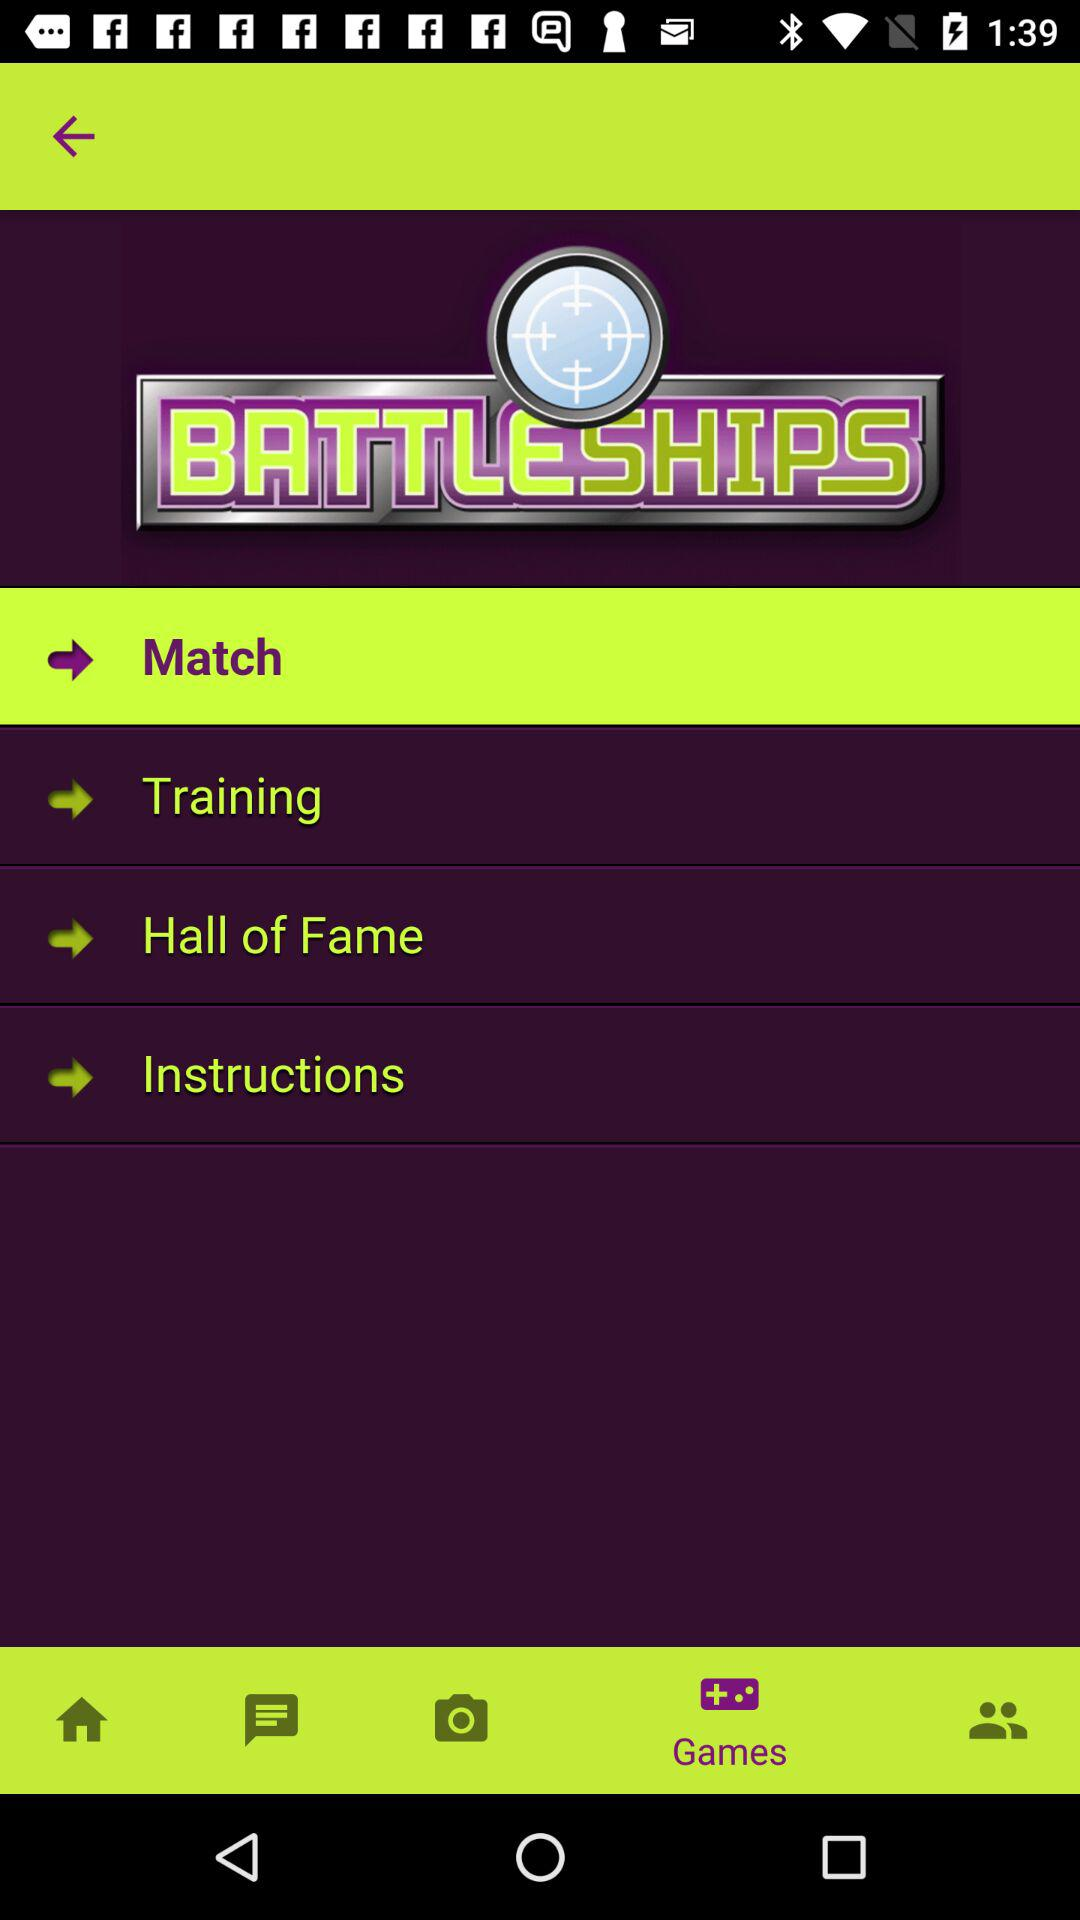What is the application name? The application name is "Battleships". 